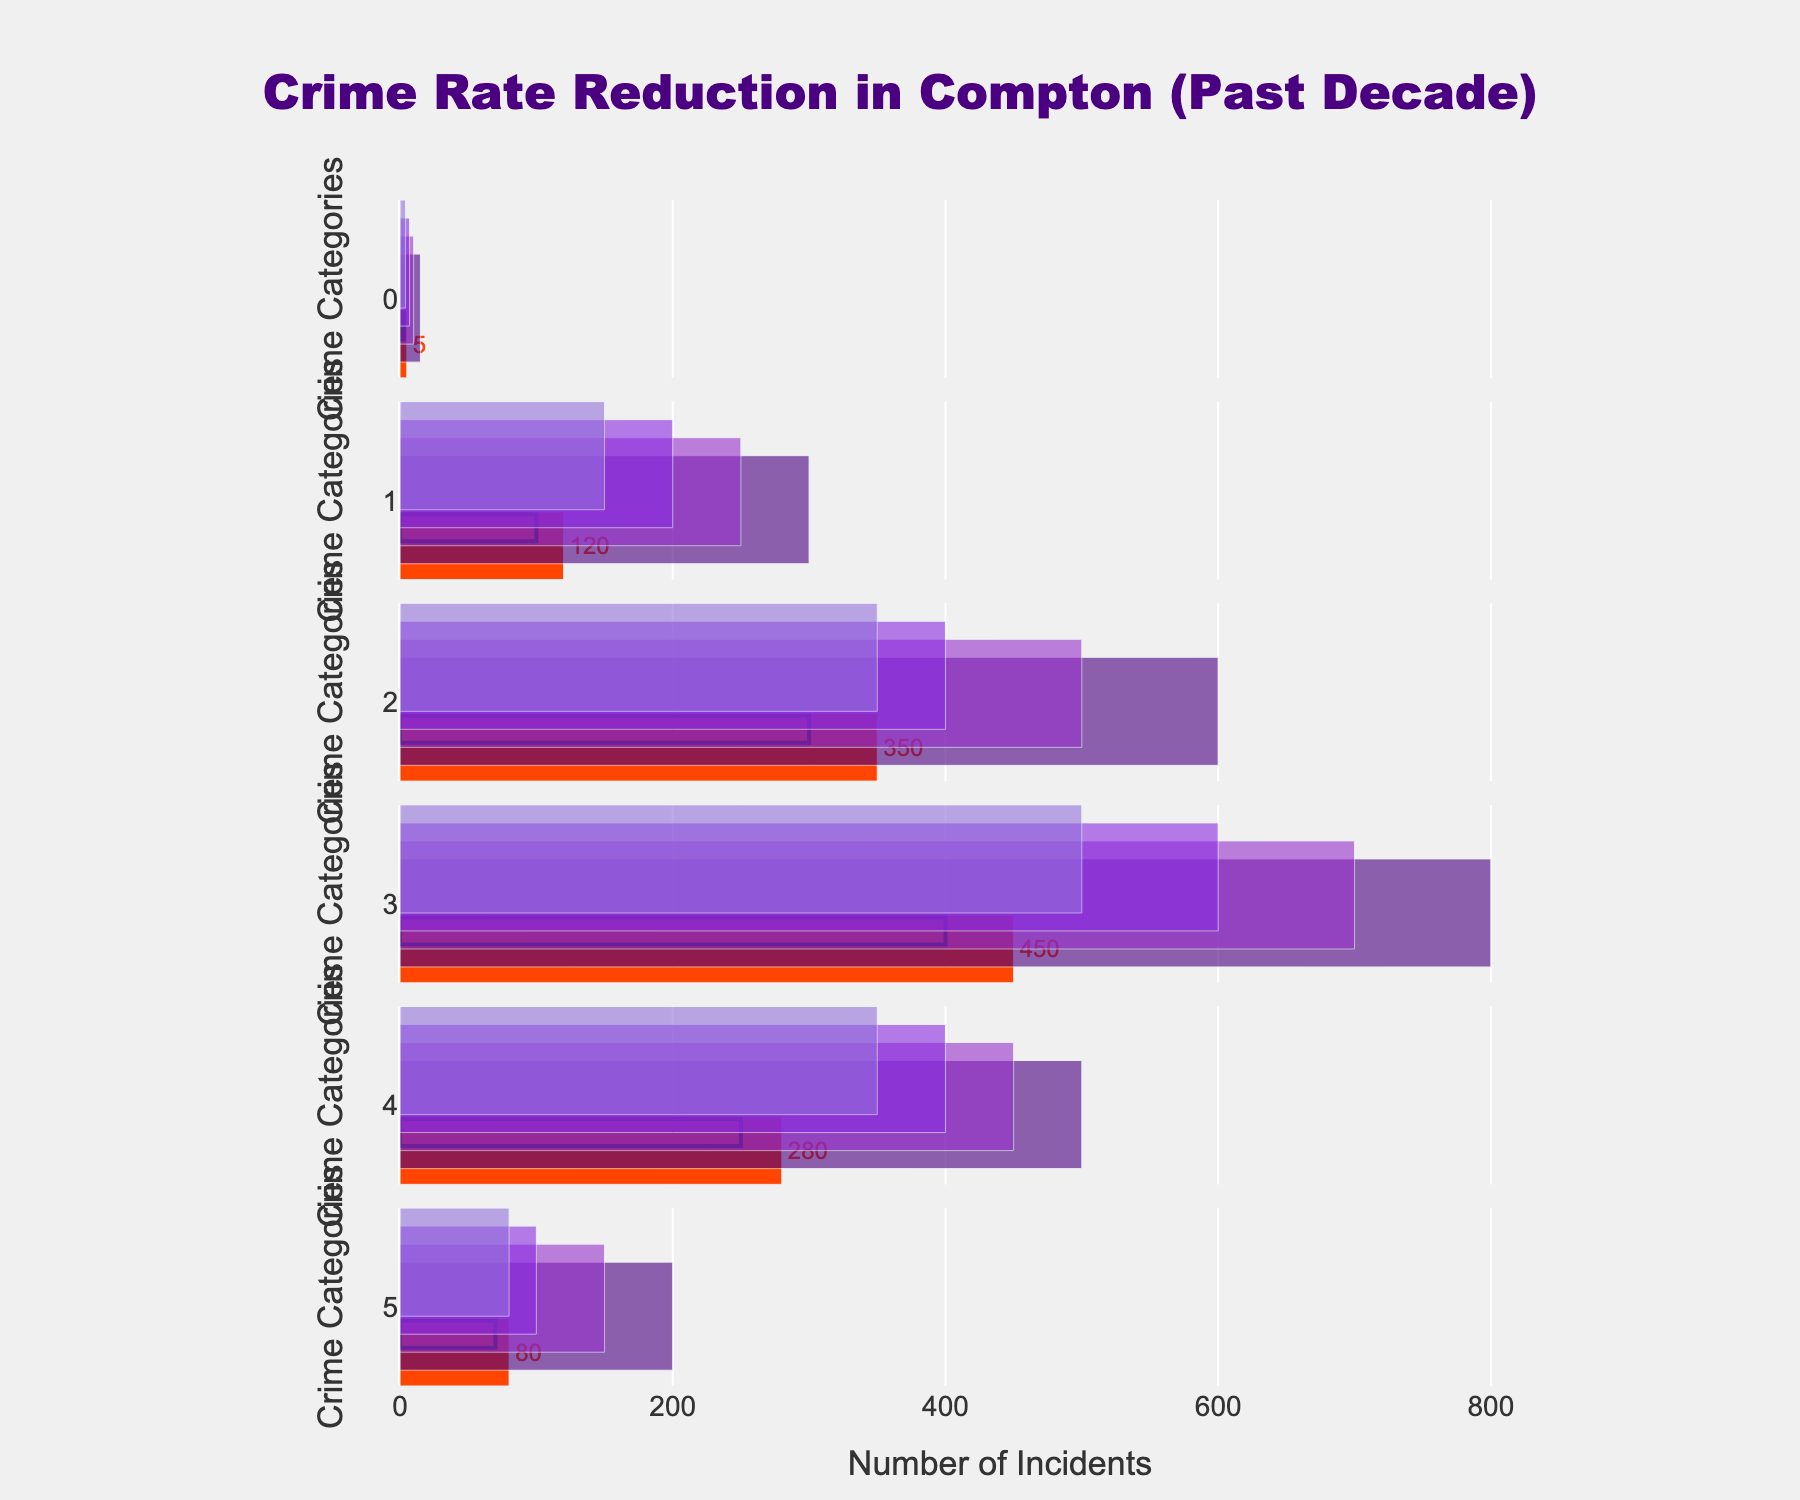What's the title of the chart? The title of the chart is placed at the top center of the figure. The plot title reads "Crime Rate Reduction in Compton (Past Decade)".
Answer: Crime Rate Reduction in Compton (Past Decade) Which crime category had the highest actual number of incidents? By examining the horizontal bars under the "Actual" category, the crime with the highest number is "Burglary" since the orange bar is the longest for this category.
Answer: Burglary What is the target value for Homicide? Look at the small black line within the horizontal bar for the "Homicide" category, which indicates the target value. The target value for Homicide is 3.
Answer: 3 Among the crimes listed, which category has the smallest difference between the actual and target values? To find the smallest difference, subtract the target value from the actual value for each crime and compare. "Gang-Related Crimes" has the smallest difference: 80 (actual) - 70 (target) = 10.
Answer: Gang-Related Crimes For Aggravated Assault, is the actual number of incidents above or below the satisfactory threshold? Locate the "Aggravated Assault" bar. The actual incidents count is 350, and the satisfactory threshold is 400. Since 350 is less than 400, it is below the satisfactory threshold.
Answer: Below Which crime category is closest to reaching its target? Calculate the difference between the actual and target values for each category and identify the smallest positive difference. "Gang-Related Crimes" is the closest with a difference of 10.
Answer: Gang-Related Crimes How many categories have actual incidents that fall into the 'Good' zone? Check the actual values against the 'Good' ranges: fewer than 4 for Homicide, fewer than 150 for Robbery, and fewer than 350 for Aggravated Assault, etc. Only "Gang-Related Crimes" has an actual value (80) that falls into its 'Good' range (80 or fewer).
Answer: 1 What range of incidents would classify Robbery as 'Bad'? The 'Bad' threshold for Robbery is between 250 and 300 incidents. Any value within this range is classified as 'Bad'.
Answer: 250 to 300 What is the average target value across all categories? Find the sum of all target values (3 + 100 + 300 + 400 + 250 + 70) and divide by the number of categories (6). The total is 1,123 divided by 6, which equals approximately 187.17.
Answer: 187.17 